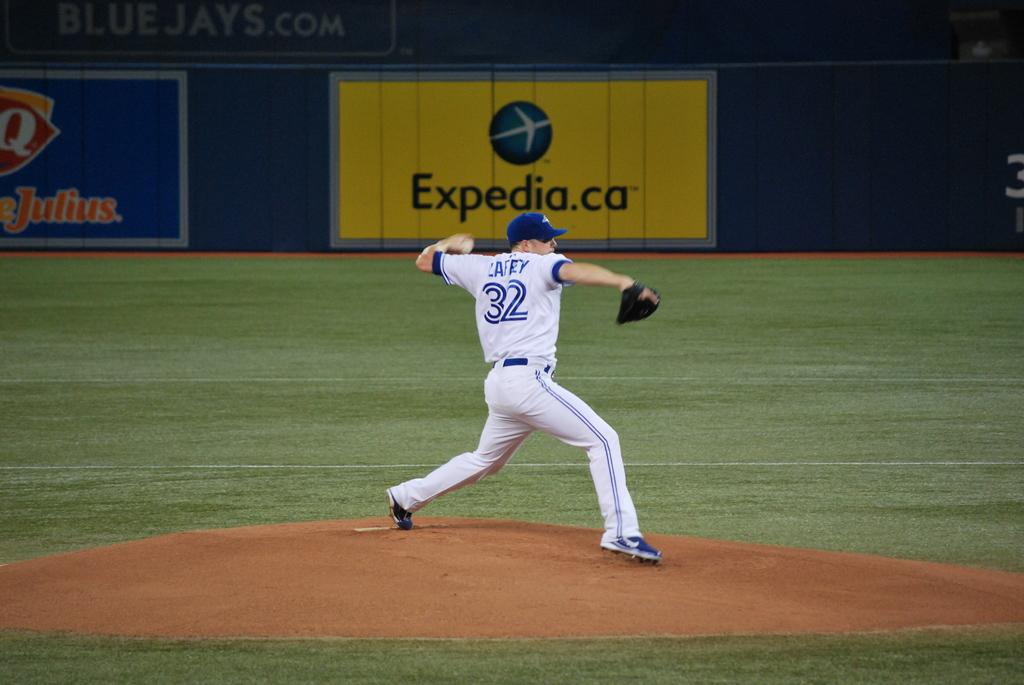<image>
Offer a succinct explanation of the picture presented. Pitcher 32 about to hurl the ball in front of an Expedia.ca advertisement behind him. 